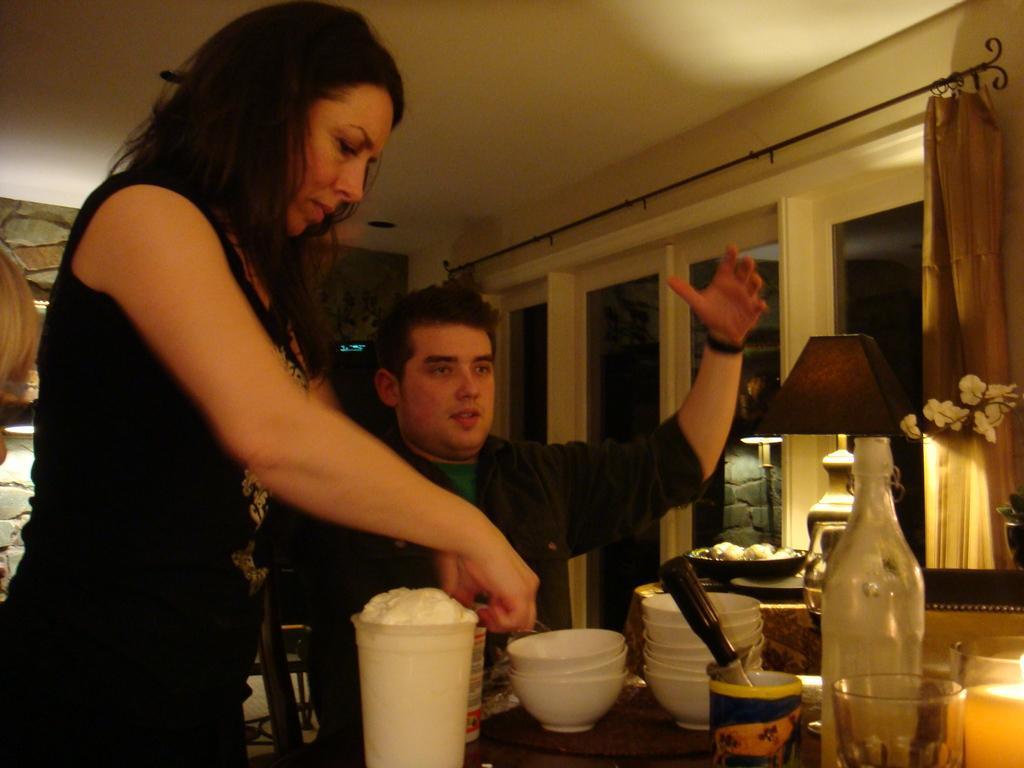Could you give a brief overview of what you see in this image? In this image there is a woman standing, beside the woman there is a man sitting on the chair, in front of them on the table there are cups, glass, a bottle, beside the table there is a lamp, behind the lamp there are curtains on the glass windows. 